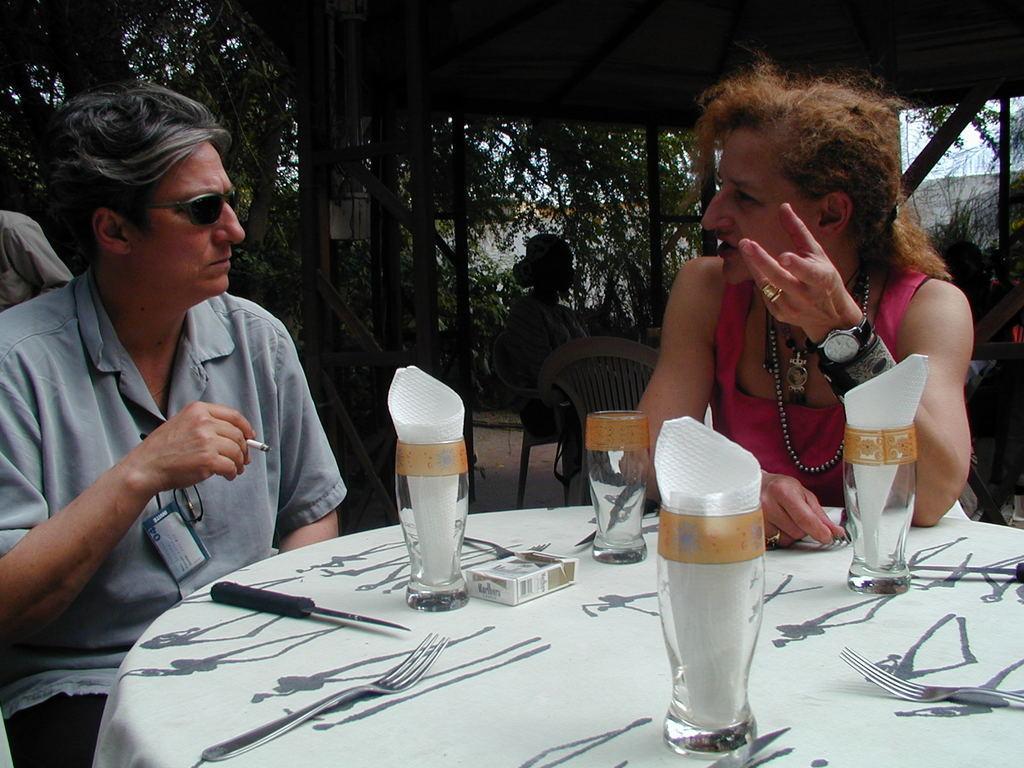Please provide a concise description of this image. In this image we can see a few people sitting on the chairs, among them, one person is holding a cigarette and there is a table, on the table, we can see some glasses, tissues, forks and some other objects, there are some trees and the wall, also we can see the sky. 